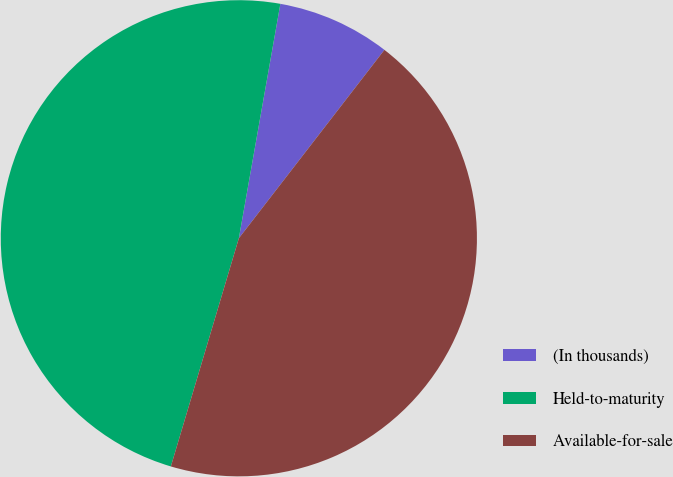Convert chart. <chart><loc_0><loc_0><loc_500><loc_500><pie_chart><fcel>(In thousands)<fcel>Held-to-maturity<fcel>Available-for-sale<nl><fcel>7.68%<fcel>48.18%<fcel>44.14%<nl></chart> 